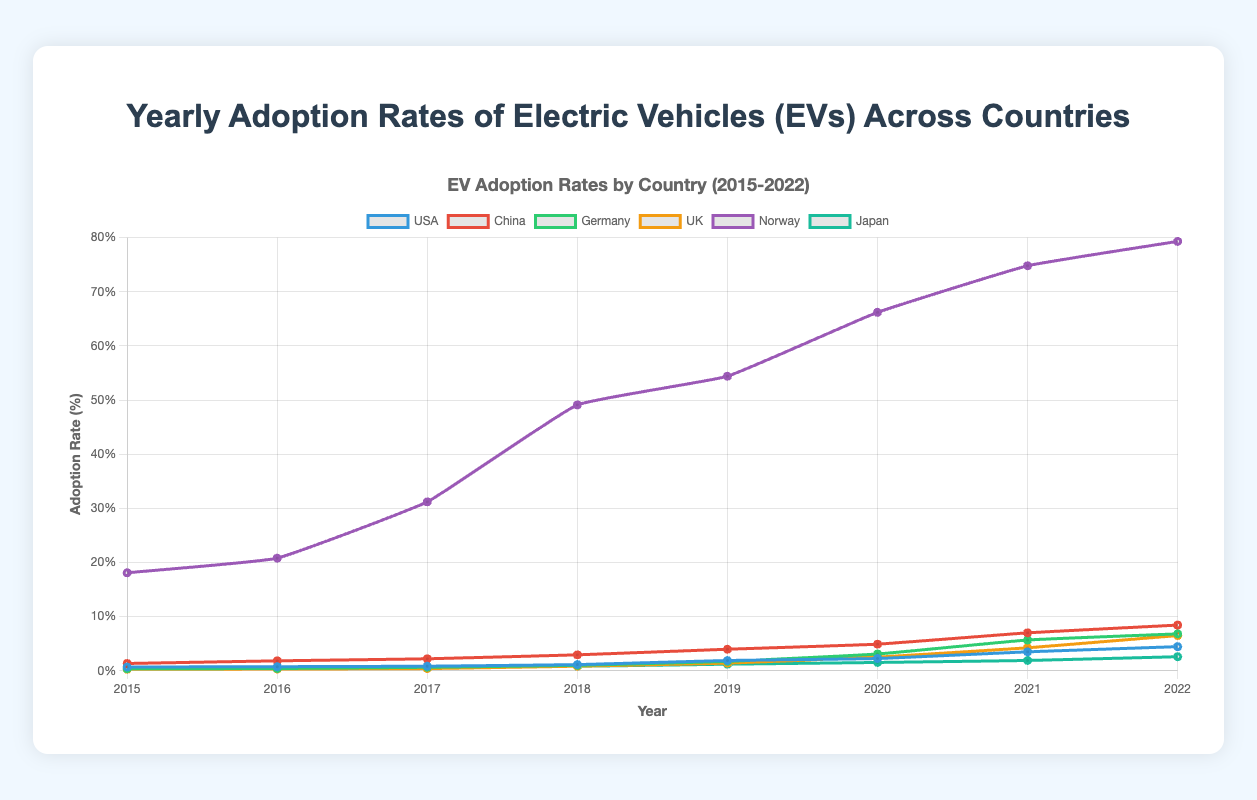Which country had the highest EV adoption rate in 2022? In 2022, you can see that Norway's line is the highest on the chart compared to all other countries.
Answer: Norway How did the EV adoption rate in the USA change from 2015 to 2022? The adoption rate in the USA in 2015 is 0.7% and it increases to 4.46% in 2022. Subtracting the 2015 rate from the 2022 rate: 4.46% - 0.7% = 3.76%.
Answer: Increased by 3.76% Between 2018 and 2022, which country showed the most significant increase in EV adoption rates? Calculate the difference between the 2022 and 2018 rates for each country. USA: 4.46-1.15=3.31, China: 8.44-2.95=5.49, Germany: 6.82-1.01=5.81, UK: 6.51-0.85=5.66, Norway: 79.3-49.1=30.2, Japan: 2.6-0.83=1.77. Norway shows the highest increase.
Answer: Norway What is the average EV adoption rate for Germany from 2015 to 2022? Sum the adoption rates for Germany over the years and then divide by the number of years: (0.38+0.42+0.65+1.01+1.74+3.1+5.69+6.82) / 8 = 2.475%.
Answer: 2.475% How does the EV adoption rate growth in the UK compare to Japan from 2015 to 2022? Compare the two countries by looking at the first and last values for each. UK: 0.28 to 6.51, Japan: 0.51 to 2.6. Calculate growth: UK: 6.51-0.28=6.23, Japan: 2.6-0.51=2.09. The increase in the UK is larger.
Answer: The UK had more growth By what percentage did China's EV adoption rate increase from 2016 to 2021? Calculate the difference between 2021 and 2016 rates, then divide by the 2016 rate and multiply by 100: ((7.01-1.84)/1.84) * 100 = 280.98%.
Answer: 280.98% Which year saw the most significant rise in Norway's EV adoption rate, and what was the rise? Look at the year-to-year differences in Norway's rates. The largest rise is between 2017 (31.2%) and 2018 (49.1%), which is a rise of 49.1-31.2=17.9%.
Answer: 2017-2018, 17.9% Compare the EV adoption rates of the USA and the UK in 2020. Which is higher and by how much? In 2020, the USA's rate is 2.27% and the UK's rate is 2.53%.  Compare the two rates: 2.53 - 2.27 = 0.26%. The UK's rate is higher by 0.26%.
Answer: The UK, by 0.26% What’s the sum of the EV adoption rates in China and Germany in 2019? Add the 2019 rates for China and Germany: 3.98% + 1.74% = 5.72%.
Answer: 5.72% If you average the EV adoption rates across all countries in 2022, what do you get? Sum the 2022 adoption rates for all countries and then divide by the number of countries: (4.46+8.44+6.82+6.51+79.3+2.6) / 6 = 18.355%.
Answer: 18.355% 